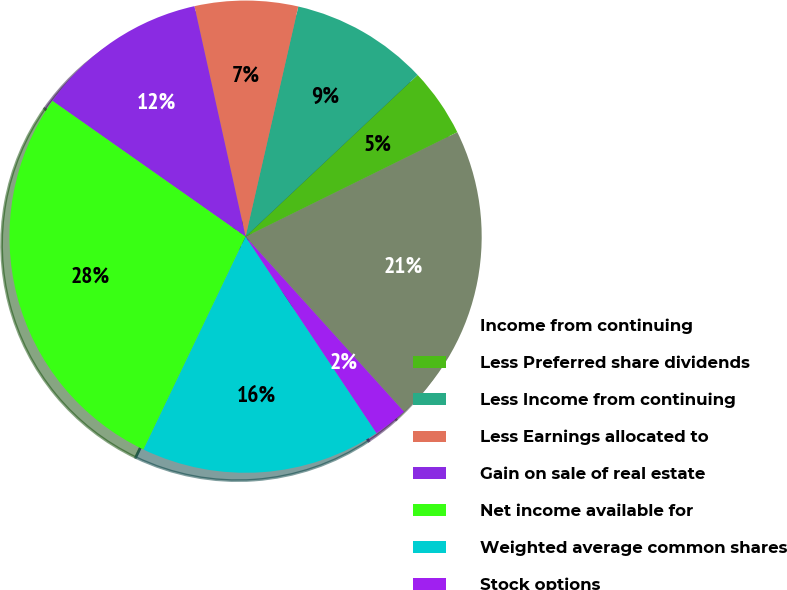Convert chart. <chart><loc_0><loc_0><loc_500><loc_500><pie_chart><fcel>Income from continuing<fcel>Less Preferred share dividends<fcel>Less Income from continuing<fcel>Less Earnings allocated to<fcel>Gain on sale of real estate<fcel>Net income available for<fcel>Weighted average common shares<fcel>Stock options<nl><fcel>20.59%<fcel>4.71%<fcel>9.41%<fcel>7.06%<fcel>11.77%<fcel>27.64%<fcel>16.47%<fcel>2.35%<nl></chart> 